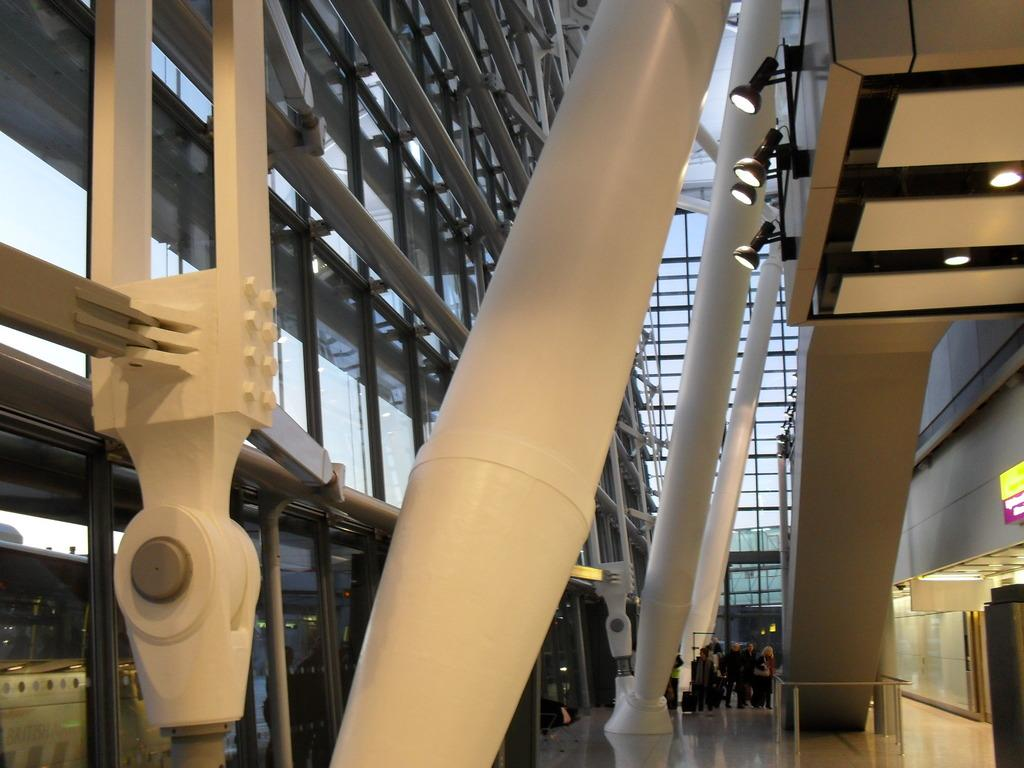What type of view is shown in the image? The image shows an inner view of a building. What can be seen inside the building? There are lights visible in the image, as well as people standing and glasses present. Can you describe the architectural feature in the building? The building appears to have a staircase. How does the brake system work in the building shown in the image? There is no mention of a brake system in the image, as it shows an inner view of a building with lights, people, glasses, and a staircase. --- 